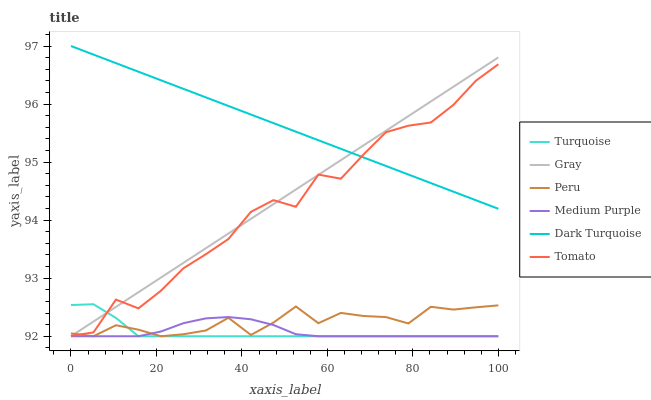Does Turquoise have the minimum area under the curve?
Answer yes or no. Yes. Does Dark Turquoise have the maximum area under the curve?
Answer yes or no. Yes. Does Gray have the minimum area under the curve?
Answer yes or no. No. Does Gray have the maximum area under the curve?
Answer yes or no. No. Is Dark Turquoise the smoothest?
Answer yes or no. Yes. Is Tomato the roughest?
Answer yes or no. Yes. Is Gray the smoothest?
Answer yes or no. No. Is Gray the roughest?
Answer yes or no. No. Does Gray have the lowest value?
Answer yes or no. Yes. Does Dark Turquoise have the lowest value?
Answer yes or no. No. Does Dark Turquoise have the highest value?
Answer yes or no. Yes. Does Gray have the highest value?
Answer yes or no. No. Is Medium Purple less than Dark Turquoise?
Answer yes or no. Yes. Is Dark Turquoise greater than Peru?
Answer yes or no. Yes. Does Tomato intersect Gray?
Answer yes or no. Yes. Is Tomato less than Gray?
Answer yes or no. No. Is Tomato greater than Gray?
Answer yes or no. No. Does Medium Purple intersect Dark Turquoise?
Answer yes or no. No. 